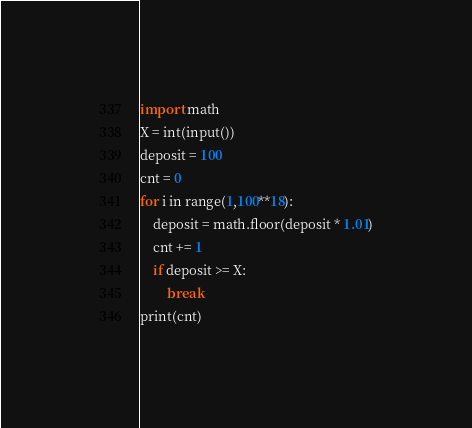Convert code to text. <code><loc_0><loc_0><loc_500><loc_500><_Python_>import math
X = int(input())
deposit = 100
cnt = 0
for i in range(1,100**18):
    deposit = math.floor(deposit * 1.01)
    cnt += 1
    if deposit >= X:
        break
print(cnt)
</code> 